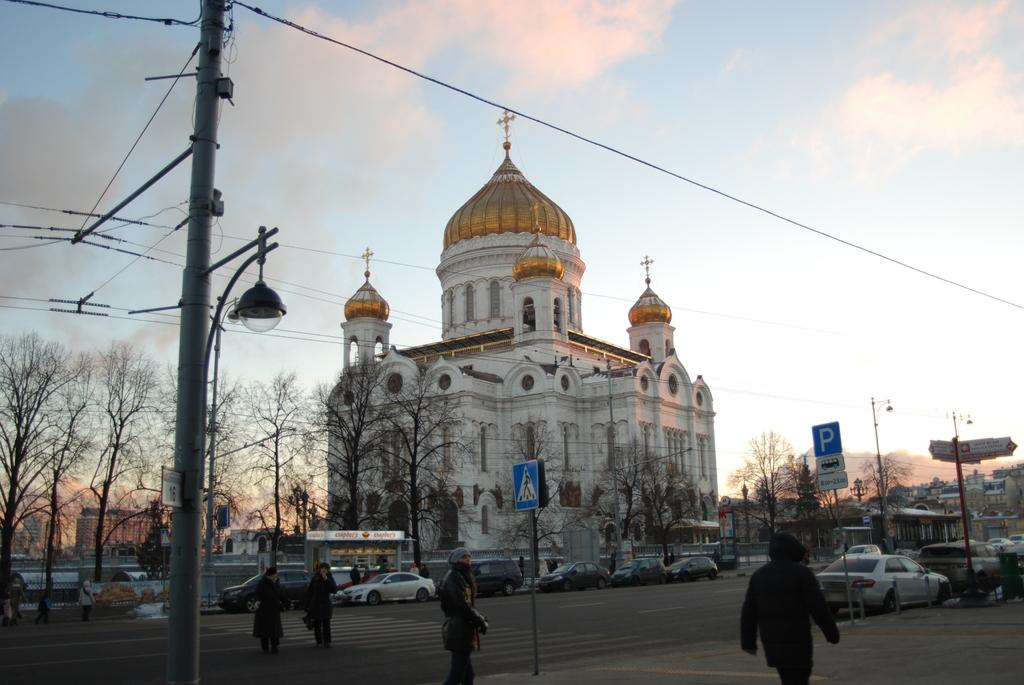What are the people in the image doing? The people in the image are crossing the road. What else can be seen on the road besides the people? There are vehicles on the road. What is located beside the road in the image? There are poles beside the road. What can be seen in the background of the image? There are trees, a church, and the sky visible in the background of the image. What type of bubble can be seen floating near the church in the image? There is no bubble present in the image; it features people crossing the road, vehicles, poles, trees, a church, and the sky. 